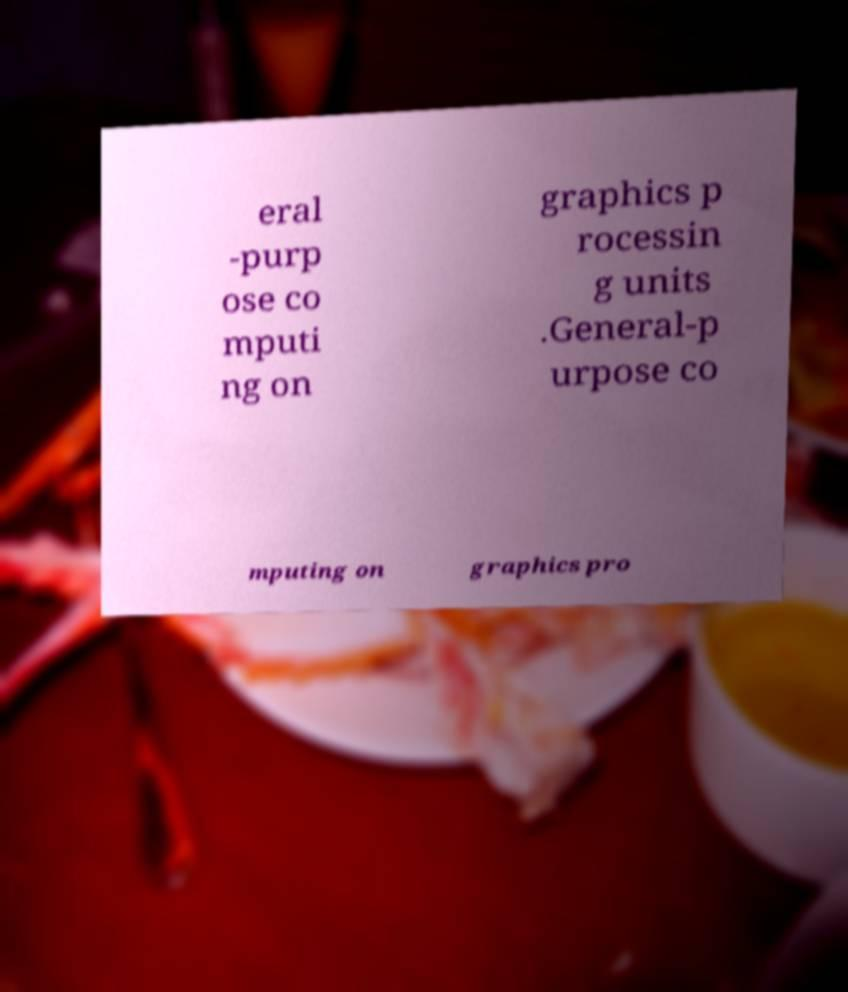For documentation purposes, I need the text within this image transcribed. Could you provide that? eral -purp ose co mputi ng on graphics p rocessin g units .General-p urpose co mputing on graphics pro 